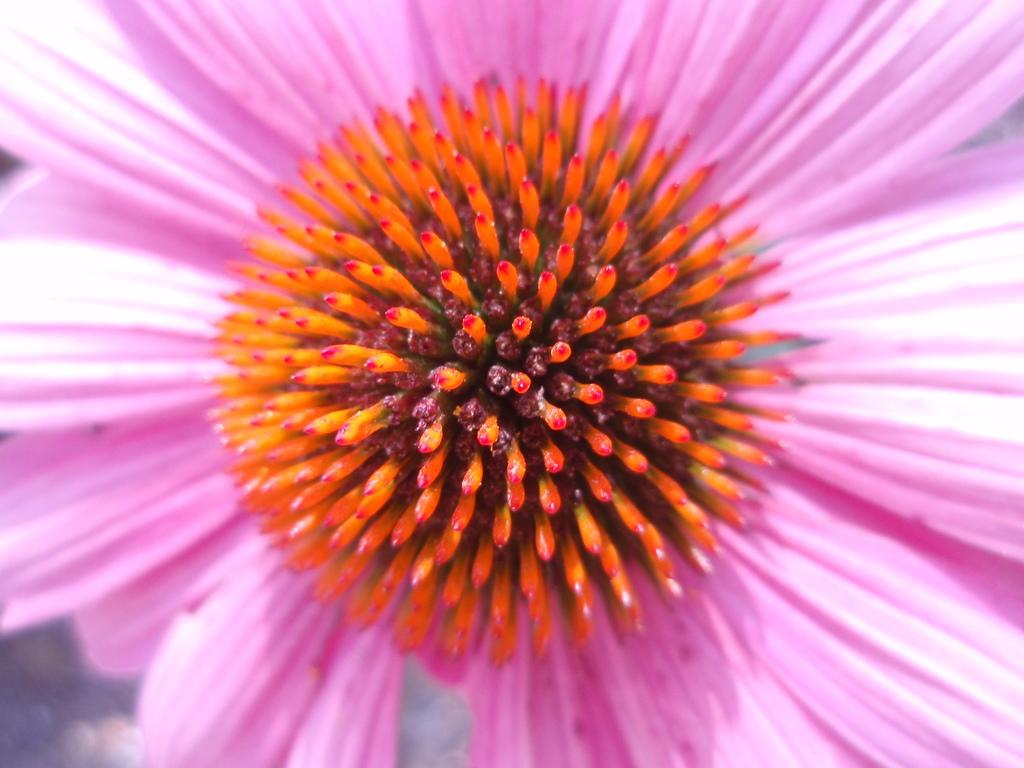What is the main subject of the picture? The main subject of the picture is a flower. Can you describe the color of the flower's petals? The flower has pink petals. What colors can be seen at the center of the flower? The flower has red and yellow colored pistils at the center. What is the name of the daughter in the picture? There is no daughter present in the image; it features a flower. Can you hear any thunder in the picture? There is no sound in the picture, and therefore no thunder can be heard. 